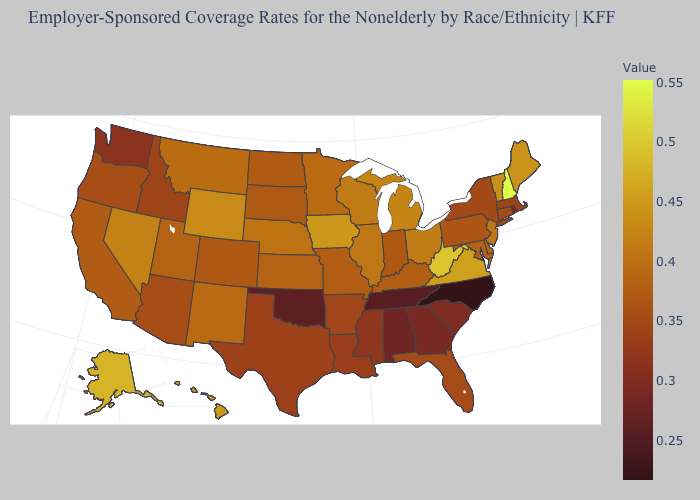Which states hav the highest value in the MidWest?
Write a very short answer. Iowa. Among the states that border Iowa , which have the lowest value?
Concise answer only. South Dakota. Does Virginia have the highest value in the USA?
Give a very brief answer. No. Does Michigan have a higher value than West Virginia?
Quick response, please. No. 